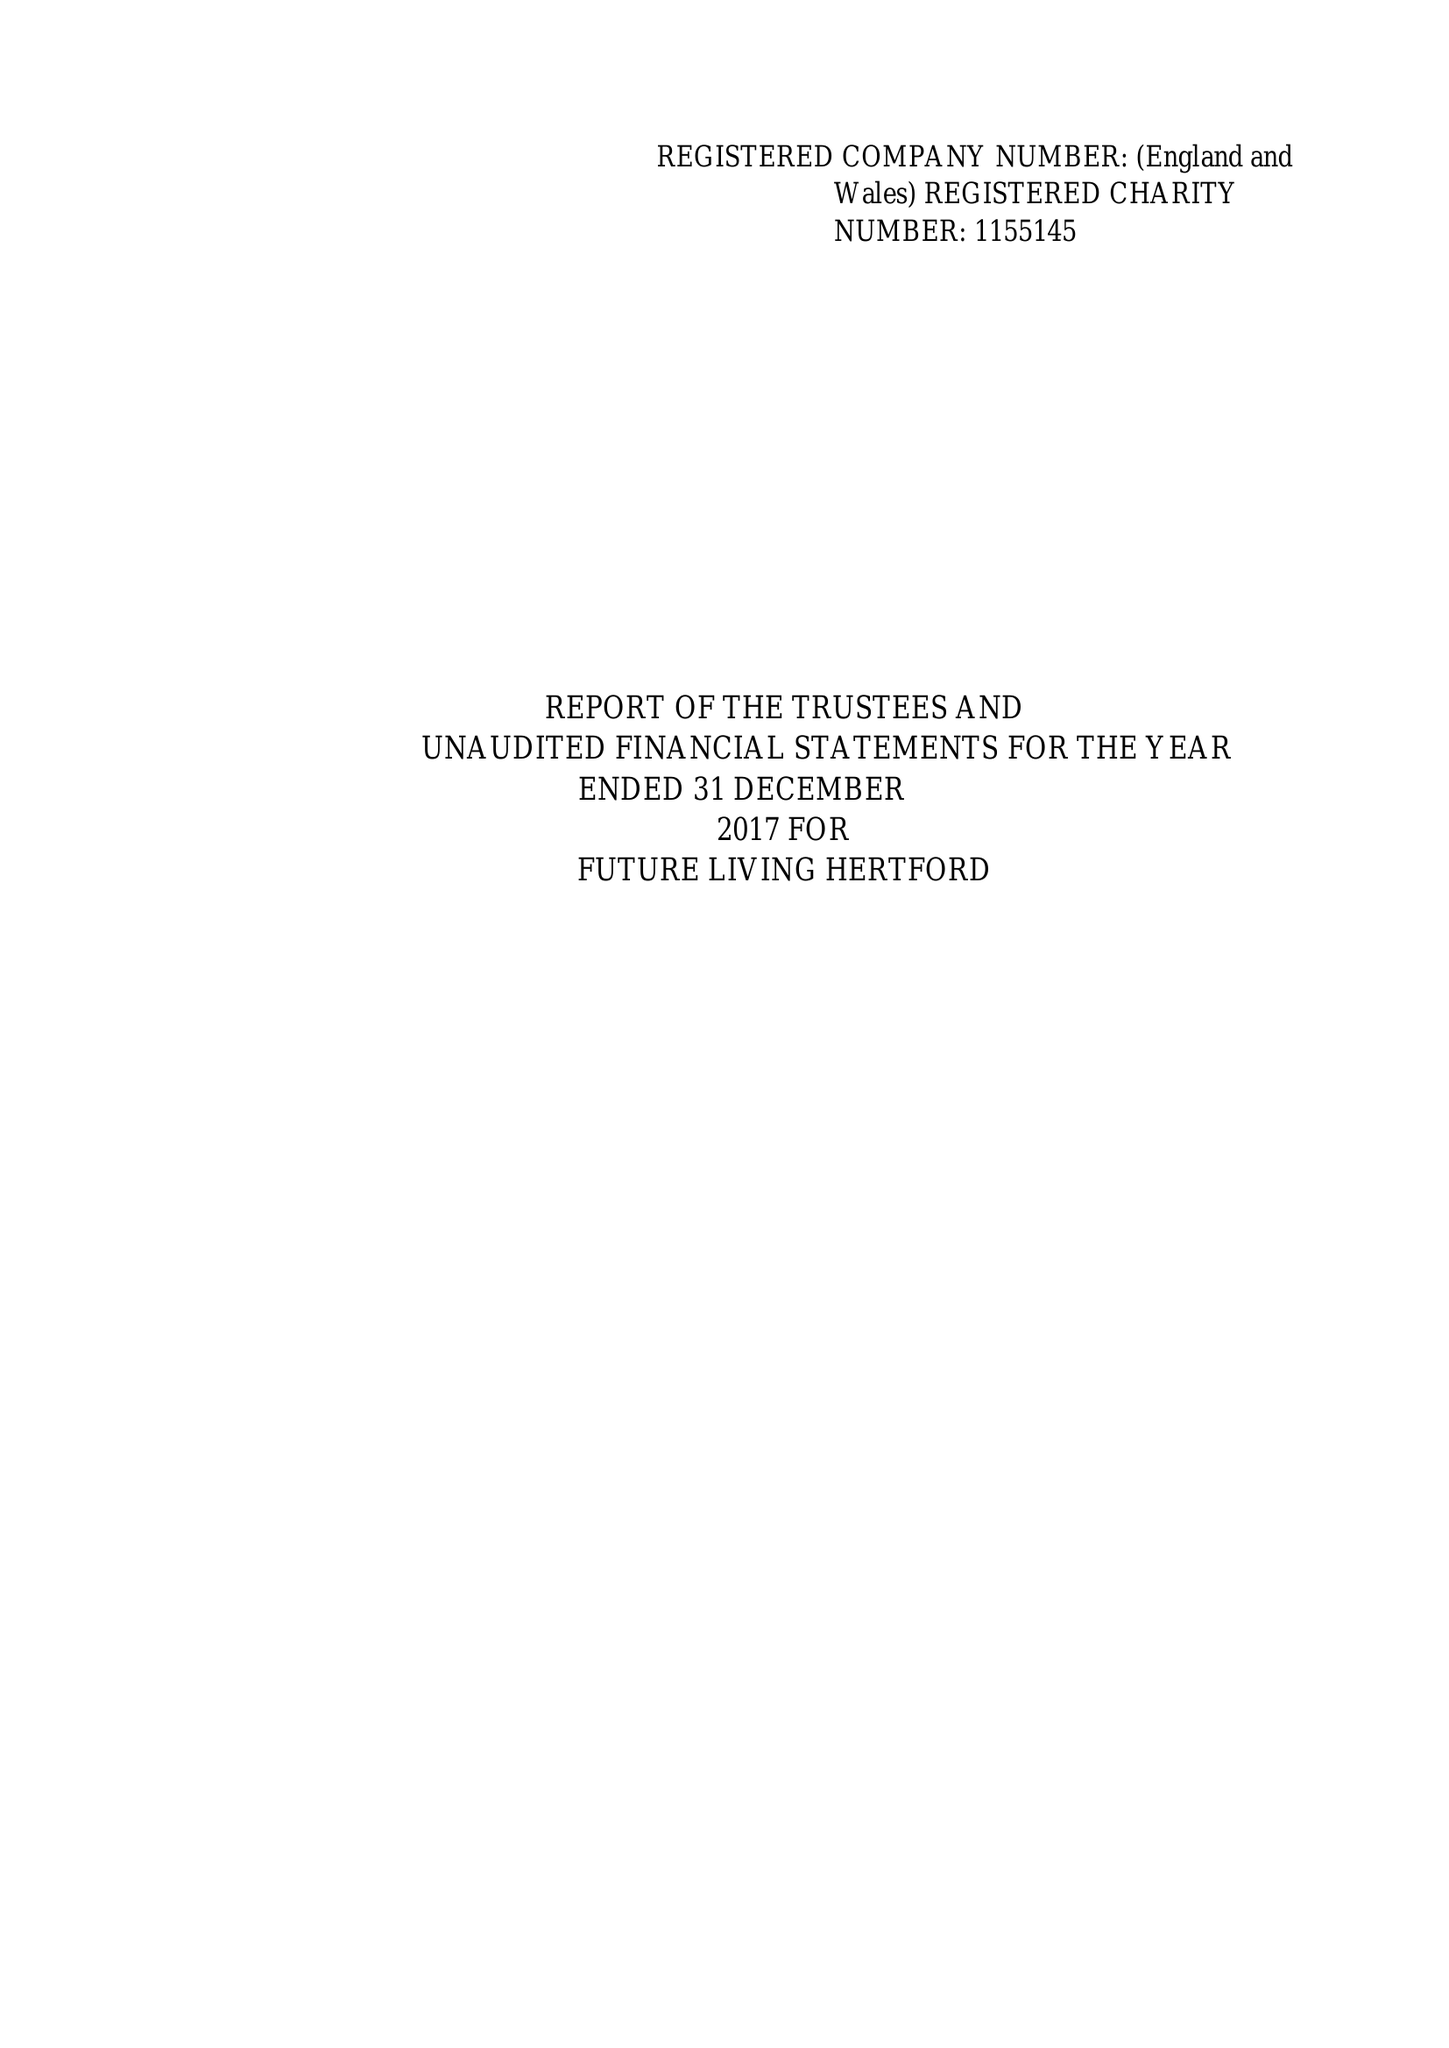What is the value for the report_date?
Answer the question using a single word or phrase. 2017-12-31 